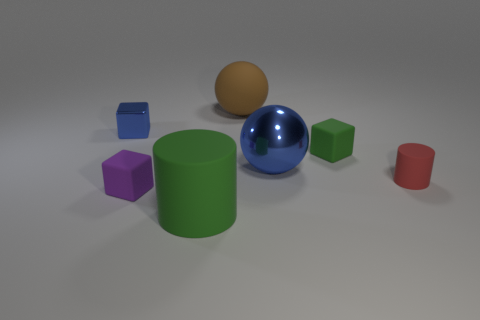There is a object that is the same color as the metallic block; what is its size?
Keep it short and to the point. Large. Are there any small purple objects made of the same material as the small purple block?
Offer a terse response. No. What is the ball right of the large brown object made of?
Your answer should be compact. Metal. There is a rubber cylinder that is on the right side of the big brown thing; is it the same color as the big thing that is on the right side of the brown ball?
Offer a terse response. No. There is a metal sphere that is the same size as the green cylinder; what color is it?
Your response must be concise. Blue. How many other things are the same shape as the large metal thing?
Keep it short and to the point. 1. There is a rubber cylinder in front of the small cylinder; how big is it?
Offer a terse response. Large. What number of blue objects are on the right side of the large rubber thing in front of the brown matte object?
Ensure brevity in your answer.  1. What number of other things are the same size as the green rubber cylinder?
Your response must be concise. 2. Is the color of the metallic cube the same as the tiny matte cylinder?
Offer a terse response. No. 